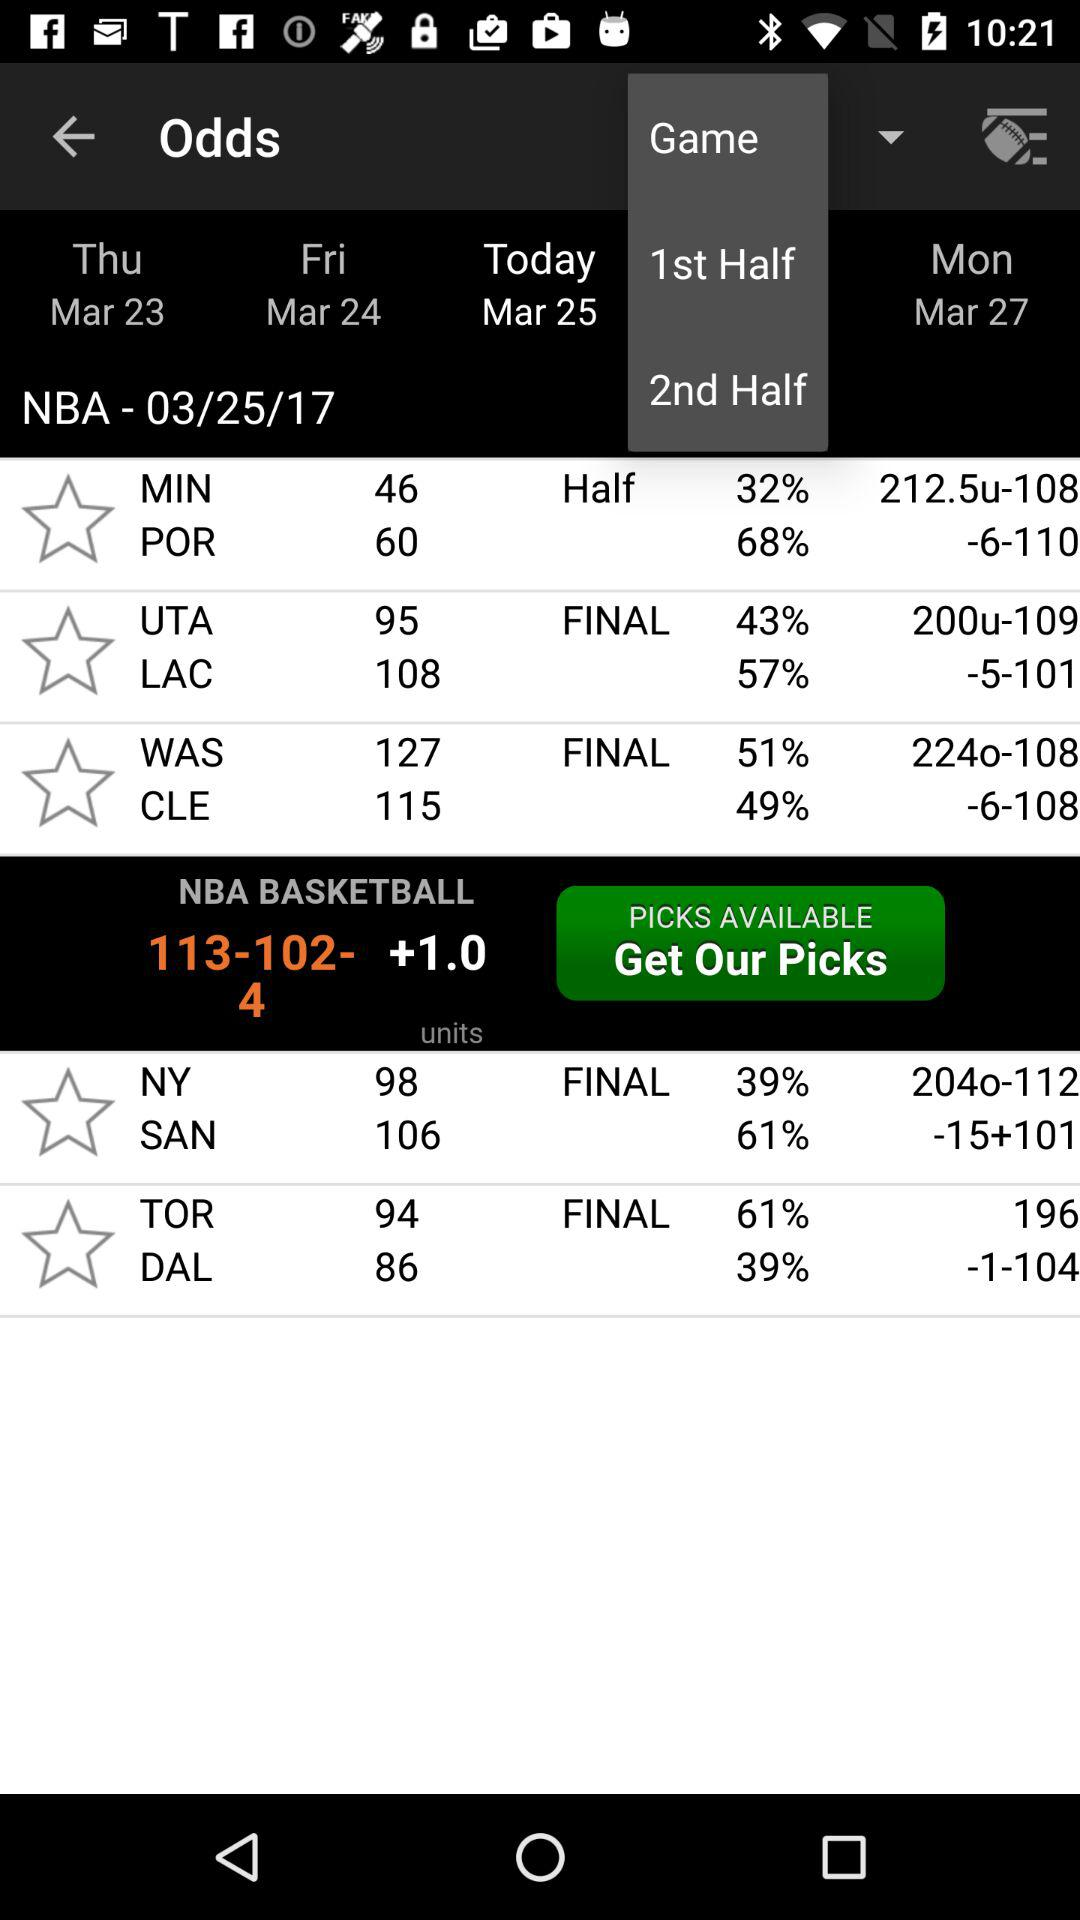What will the date be on Monday? The date will be March 27. 